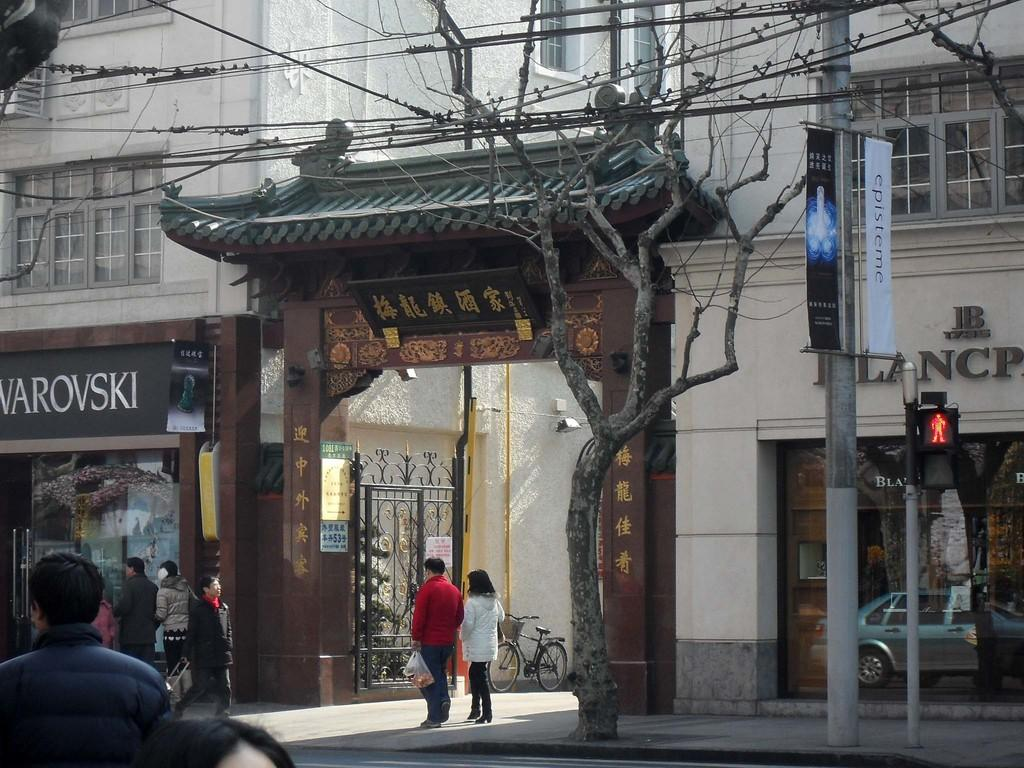How many people can be seen in the image? There are people in the image, but the exact number is not specified. What are some of the people doing in the image? Some people are walking in the image. What type of vegetation is present in the image? There is a dried tree in the image. What type of man-made structures can be seen in the image? There are boards, a traffic signal on poles and wires, and a building in the background of the image. What can be seen in the background of the image? In the background of the image, there is a bicycle, a gate, and windows. Can you see a rifle in the image? No, there is no rifle present in the image. What type of fowl can be seen in the background of the image? There is no fowl present in the image. 